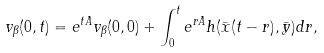<formula> <loc_0><loc_0><loc_500><loc_500>v _ { \beta } ( 0 , t ) = e ^ { t A } v _ { \beta } ( 0 , 0 ) + \int _ { 0 } ^ { t } e ^ { r A } h ( \bar { x } ( t - r ) , \bar { y } ) d r ,</formula> 